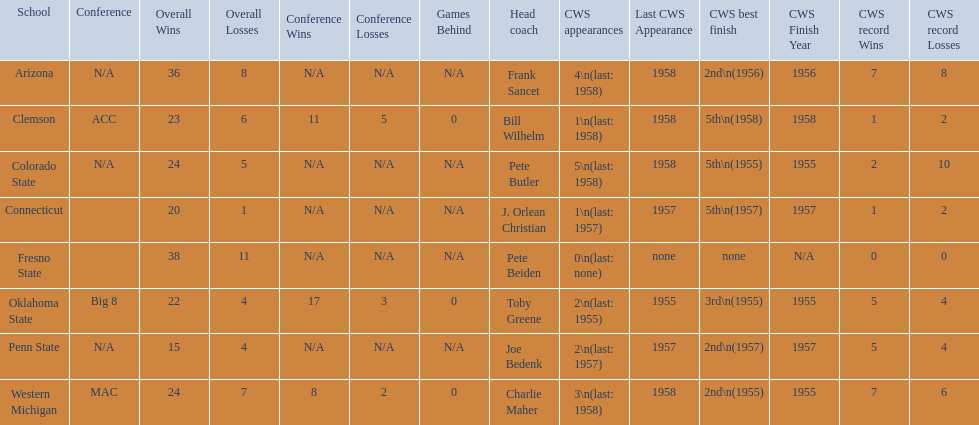What are all of the schools? Arizona, Clemson, Colorado State, Connecticut, Fresno State, Oklahoma State, Penn State, Western Michigan. Which team had fewer than 20 wins? Penn State. 